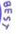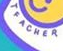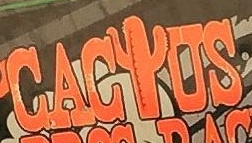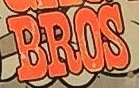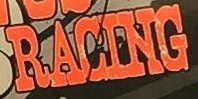Identify the words shown in these images in order, separated by a semicolon. BEST; TEACHER; CACIUS; BROS; RACING 